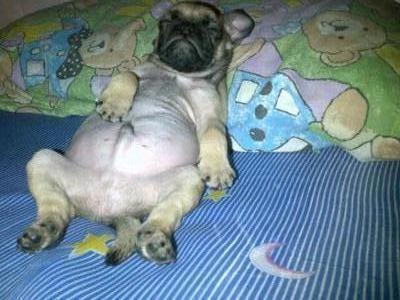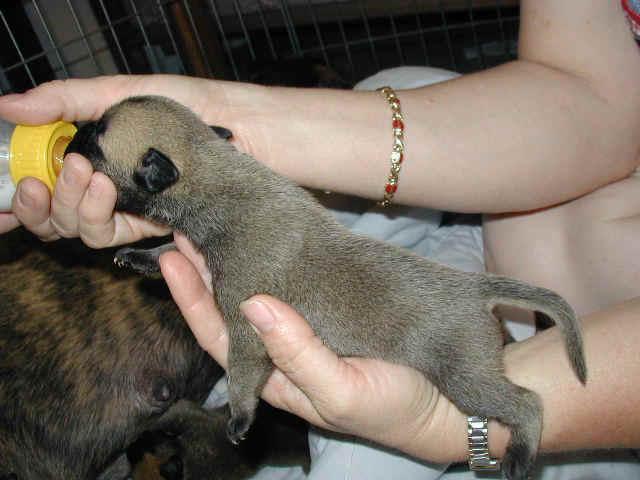The first image is the image on the left, the second image is the image on the right. For the images displayed, is the sentence "In one of the images you can see someone feeding a puppy from a bottle." factually correct? Answer yes or no. Yes. The first image is the image on the left, the second image is the image on the right. Given the left and right images, does the statement "Someone is feeding a puppy with a baby bottle in one image, and the other image contains one 'real' pug dog." hold true? Answer yes or no. Yes. 